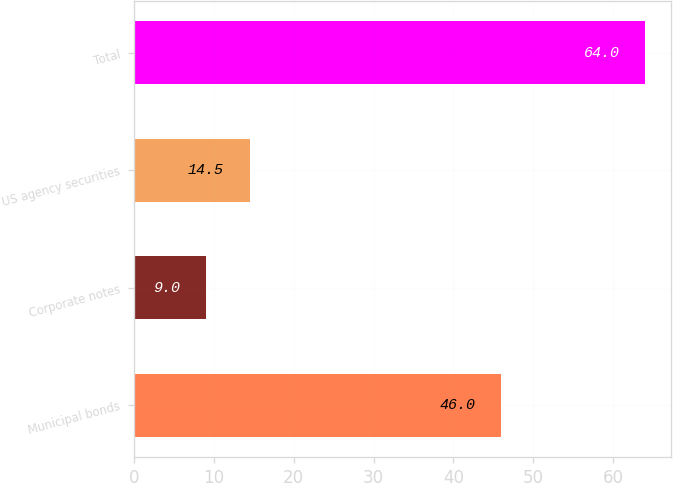Convert chart. <chart><loc_0><loc_0><loc_500><loc_500><bar_chart><fcel>Municipal bonds<fcel>Corporate notes<fcel>US agency securities<fcel>Total<nl><fcel>46<fcel>9<fcel>14.5<fcel>64<nl></chart> 